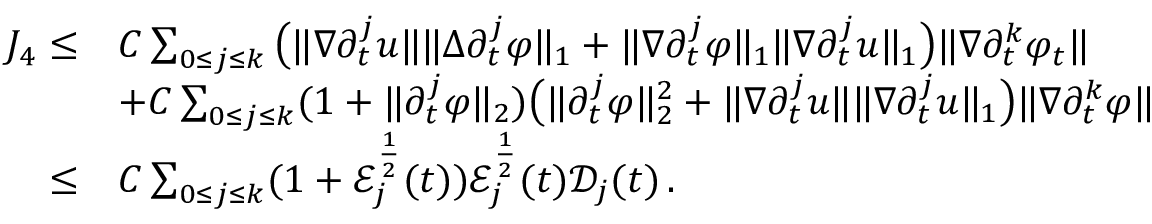Convert formula to latex. <formula><loc_0><loc_0><loc_500><loc_500>\begin{array} { r l } { J _ { 4 } \leq } & { C \sum _ { 0 \leq j \leq k } \left ( \| \nabla \partial _ { t } ^ { j } u \| \| \Delta \partial _ { t } ^ { j } \varphi \| _ { 1 } + \| \nabla \partial _ { t } ^ { j } \varphi \| _ { 1 } \| \nabla \partial _ { t } ^ { j } u \| _ { 1 } \right ) \| \nabla \partial _ { t } ^ { k } \varphi _ { t } \| } \\ & { + C \sum _ { 0 \leq j \leq k } ( 1 + \| \partial _ { t } ^ { j } \varphi \| _ { 2 } ) \left ( \| \partial _ { t } ^ { j } \varphi \| _ { 2 } ^ { 2 } + \| \nabla \partial _ { t } ^ { j } u \| \| \nabla \partial _ { t } ^ { j } u \| _ { 1 } \right ) \| \nabla \partial _ { t } ^ { k } \varphi \| } \\ { \leq } & { C \sum _ { 0 \leq j \leq k } ( 1 + \mathcal { E } _ { j } ^ { \frac { 1 } { 2 } } ( t ) ) \mathcal { E } _ { j } ^ { \frac { 1 } { 2 } } ( t ) \mathcal { D } _ { j } ( t ) \, . } \end{array}</formula> 